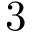Convert formula to latex. <formula><loc_0><loc_0><loc_500><loc_500>3</formula> 